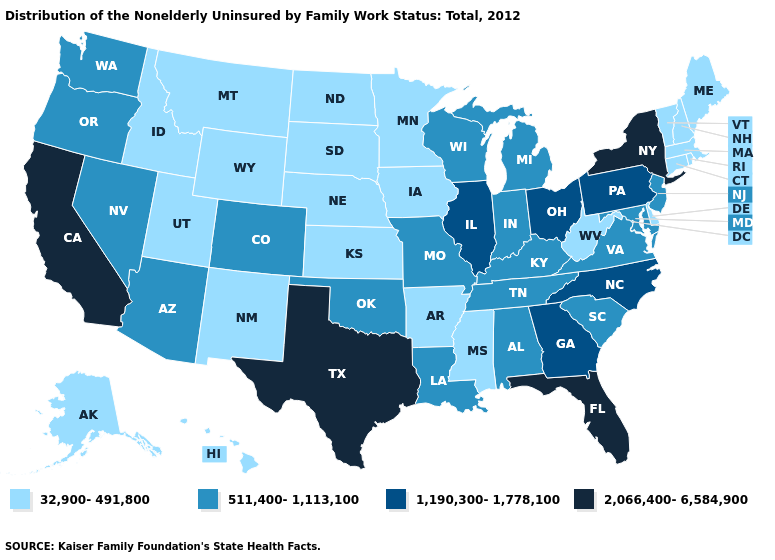What is the lowest value in the USA?
Short answer required. 32,900-491,800. How many symbols are there in the legend?
Concise answer only. 4. Does Idaho have the same value as Alaska?
Quick response, please. Yes. What is the highest value in the USA?
Be succinct. 2,066,400-6,584,900. Among the states that border Wyoming , does South Dakota have the lowest value?
Quick response, please. Yes. What is the lowest value in the MidWest?
Concise answer only. 32,900-491,800. Name the states that have a value in the range 2,066,400-6,584,900?
Quick response, please. California, Florida, New York, Texas. What is the value of Michigan?
Give a very brief answer. 511,400-1,113,100. What is the value of Montana?
Concise answer only. 32,900-491,800. What is the highest value in the USA?
Concise answer only. 2,066,400-6,584,900. How many symbols are there in the legend?
Give a very brief answer. 4. What is the highest value in states that border Indiana?
Concise answer only. 1,190,300-1,778,100. Among the states that border North Carolina , does Georgia have the highest value?
Quick response, please. Yes. Does North Carolina have the highest value in the South?
Concise answer only. No. What is the value of Indiana?
Be succinct. 511,400-1,113,100. 